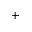<formula> <loc_0><loc_0><loc_500><loc_500>^ { + }</formula> 